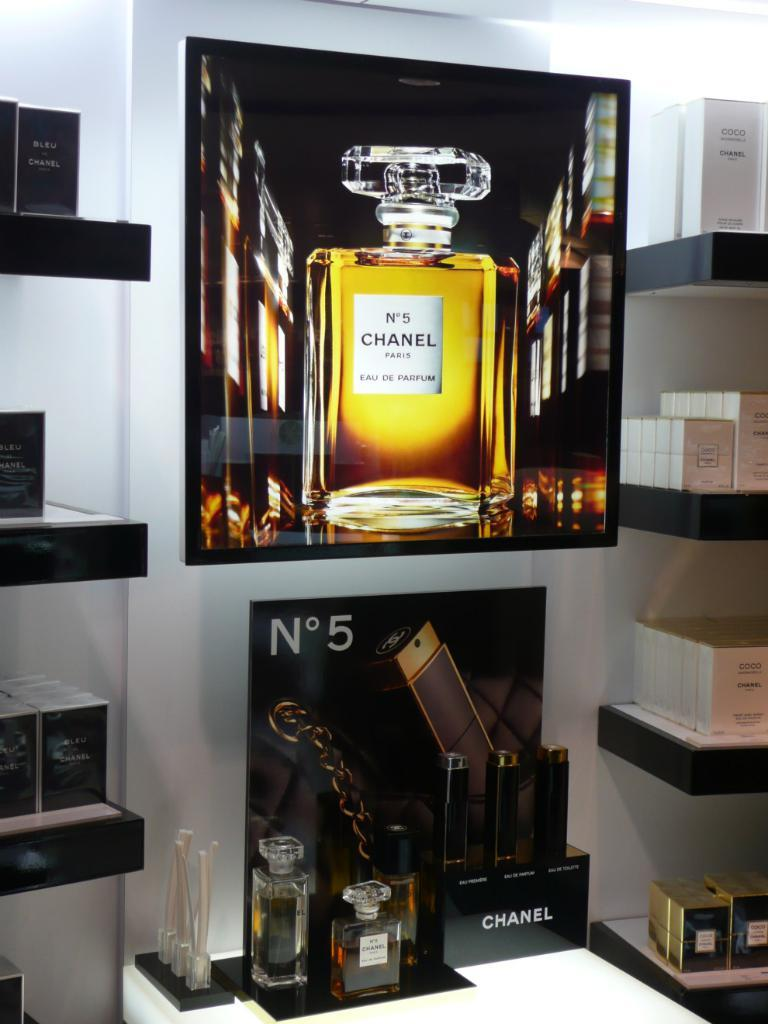<image>
Describe the image concisely. A display for the scent Chanel No. 5. 